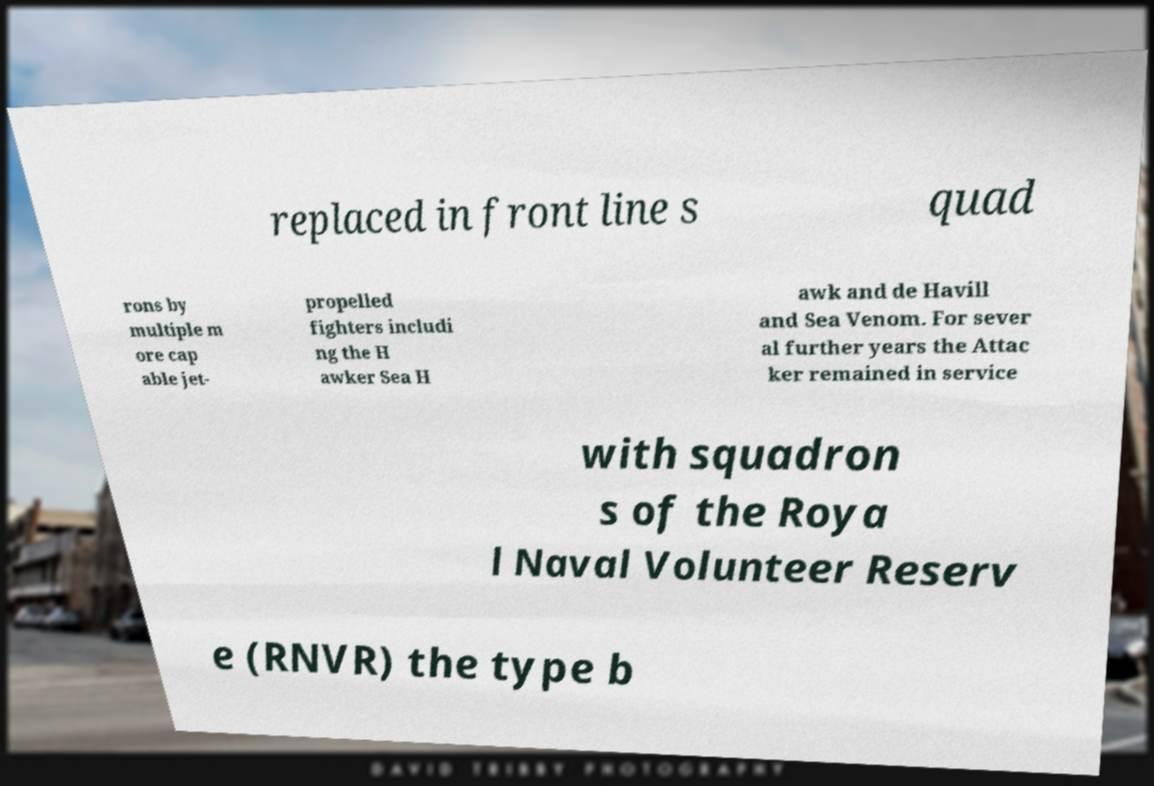Please read and relay the text visible in this image. What does it say? replaced in front line s quad rons by multiple m ore cap able jet- propelled fighters includi ng the H awker Sea H awk and de Havill and Sea Venom. For sever al further years the Attac ker remained in service with squadron s of the Roya l Naval Volunteer Reserv e (RNVR) the type b 